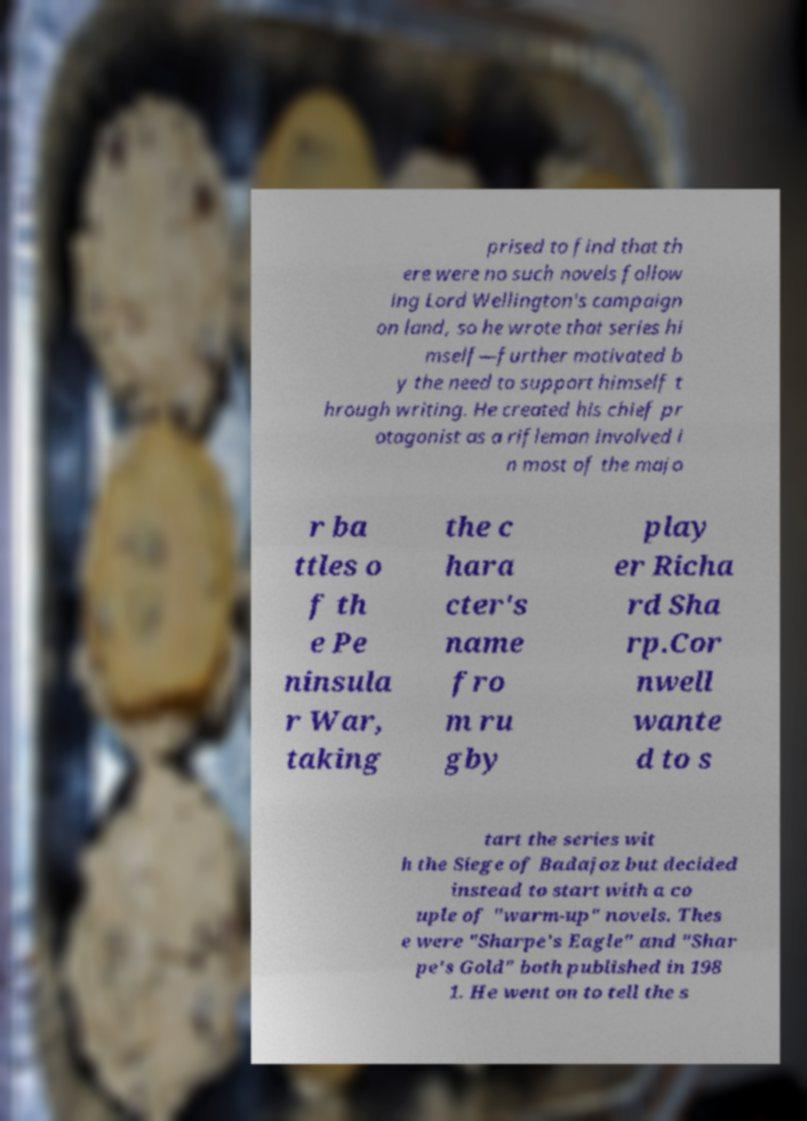There's text embedded in this image that I need extracted. Can you transcribe it verbatim? prised to find that th ere were no such novels follow ing Lord Wellington's campaign on land, so he wrote that series hi mself—further motivated b y the need to support himself t hrough writing. He created his chief pr otagonist as a rifleman involved i n most of the majo r ba ttles o f th e Pe ninsula r War, taking the c hara cter's name fro m ru gby play er Richa rd Sha rp.Cor nwell wante d to s tart the series wit h the Siege of Badajoz but decided instead to start with a co uple of "warm-up" novels. Thes e were "Sharpe's Eagle" and "Shar pe's Gold" both published in 198 1. He went on to tell the s 